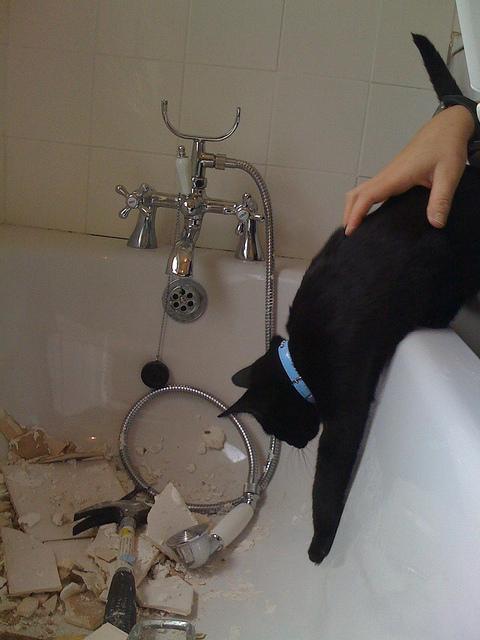Where is this cat?
Quick response, please. Bathtub. Is the cat ready for a bath?
Be succinct. No. What color is the hose on the left of the picture?
Answer briefly. Silver. Can an adult bathe here?
Quick response, please. Yes. Where is the cat?
Keep it brief. Edge of tub. Where is this cat laying?
Be succinct. Bathtub. Which hand holds the object?
Quick response, please. Right. Is the cat sitting in the sink?
Quick response, please. No. Is there any trash in the bathtub?
Quick response, please. Yes. How do you think the cat is feeling?
Concise answer only. Curious. What color is the cat?
Keep it brief. Black. What is the cat doing?
Concise answer only. Climbing in tub. How many thumbs are visible?
Give a very brief answer. 1. 